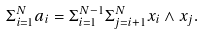<formula> <loc_0><loc_0><loc_500><loc_500>\Sigma _ { i = 1 } ^ { N } a _ { i } = \Sigma _ { i = 1 } ^ { N - 1 } \Sigma _ { j = i + 1 } ^ { N } x _ { i } \wedge x _ { j } .</formula> 